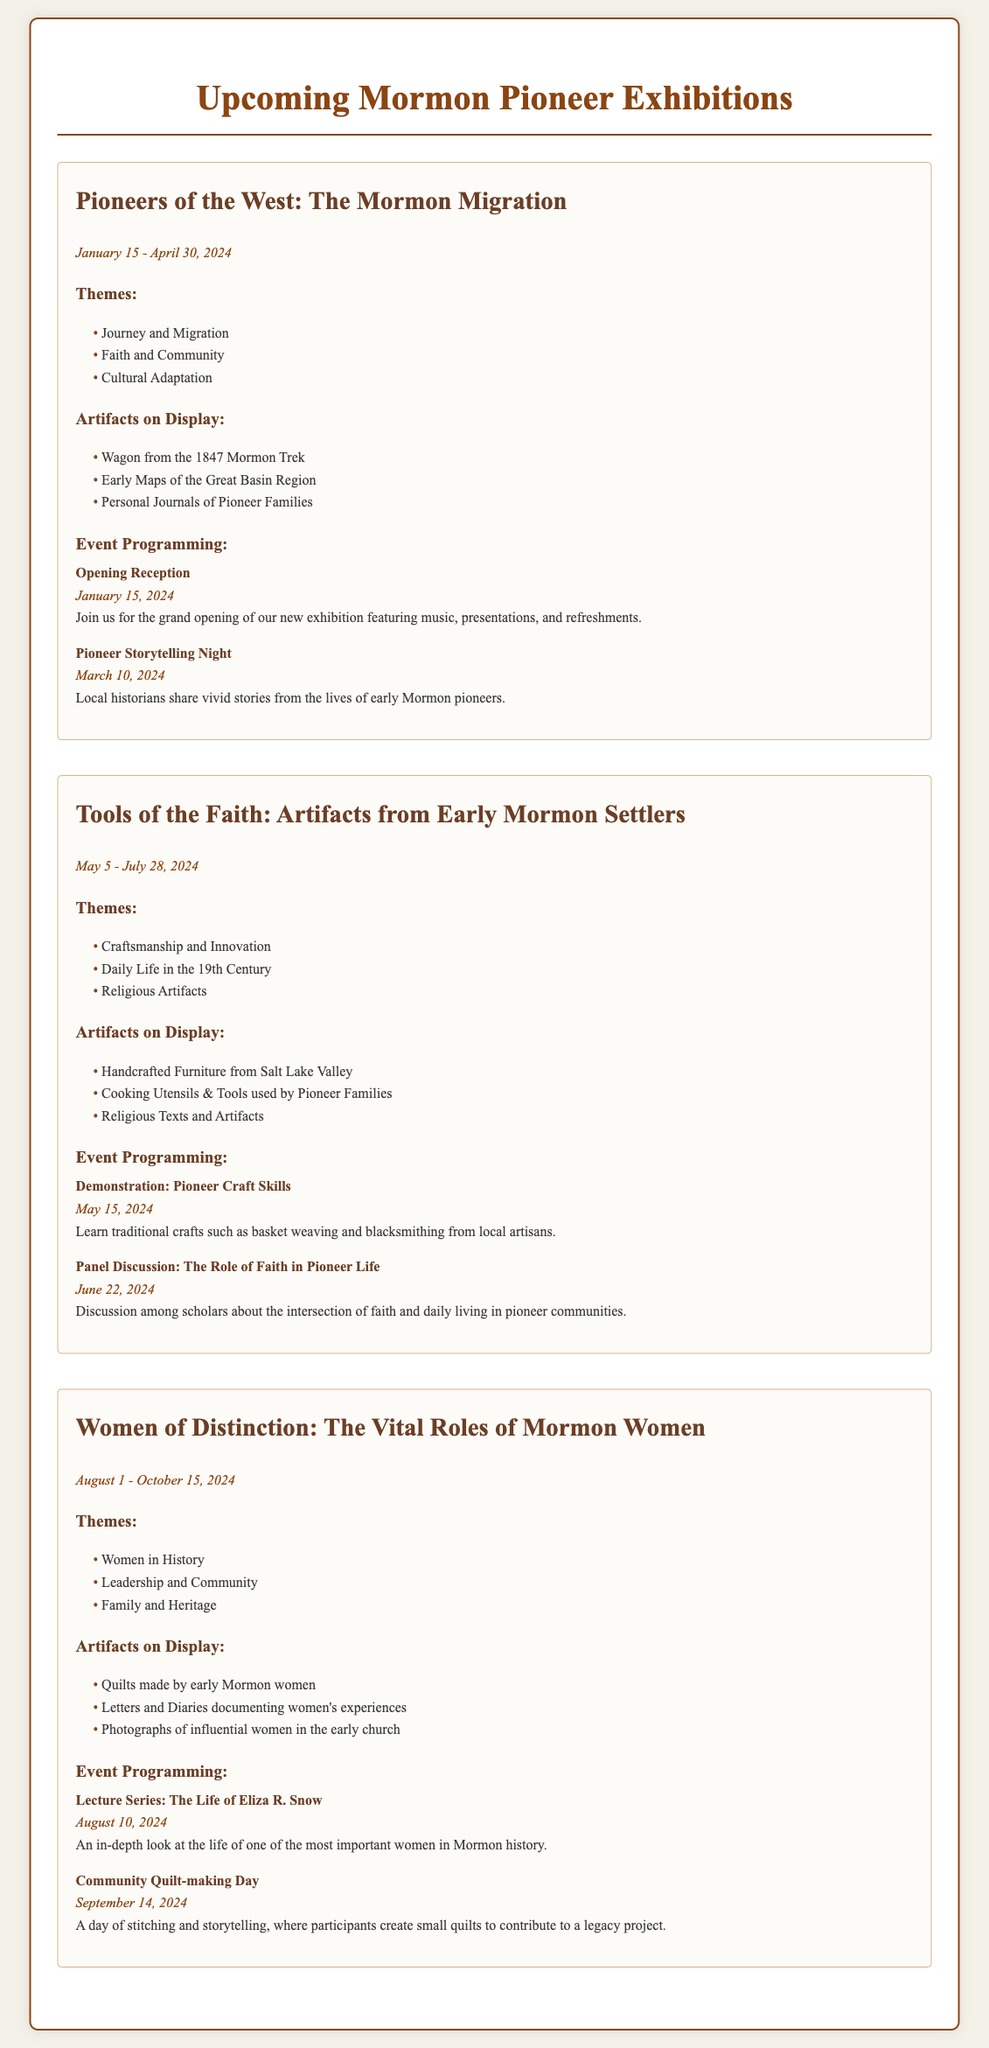What is the title of the first exhibition? The first exhibition is titled "Pioneers of the West: The Mormon Migration."
Answer: Pioneers of the West: The Mormon Migration When does the "Tools of the Faith" exhibition run? The "Tools of the Faith" exhibition runs from May 5 to July 28, 2024.
Answer: May 5 - July 28, 2024 What artifact from the first exhibition is related to travel? The artifact related to travel in the first exhibition is a wagon.
Answer: Wagon from the 1847 Mormon Trek What is one theme explored in the "Women of Distinction" exhibition? One theme explored in the "Women of Distinction" exhibition is "Women in History."
Answer: Women in History How many events are scheduled for the "Tools of the Faith" exhibition? There are two events scheduled for the "Tools of the Faith" exhibition.
Answer: Two events What date is the opening reception for the first exhibition? The opening reception for the first exhibition is on January 15, 2024.
Answer: January 15, 2024 What type of event is scheduled on September 14, 2024? The event scheduled on September 14, 2024, is a Community Quilt-making Day.
Answer: Community Quilt-making Day What is the theme of the exhibition running from August 1 to October 15, 2024? The theme of the exhibition running during that period is "Women in History."
Answer: Women in History 